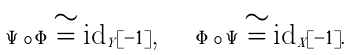<formula> <loc_0><loc_0><loc_500><loc_500>\Psi \circ \Phi \cong \text {id} _ { Y } [ - 1 ] \text {, \quad} \Phi \circ \Psi \cong \text {id} _ { X } [ - 1 ] .</formula> 